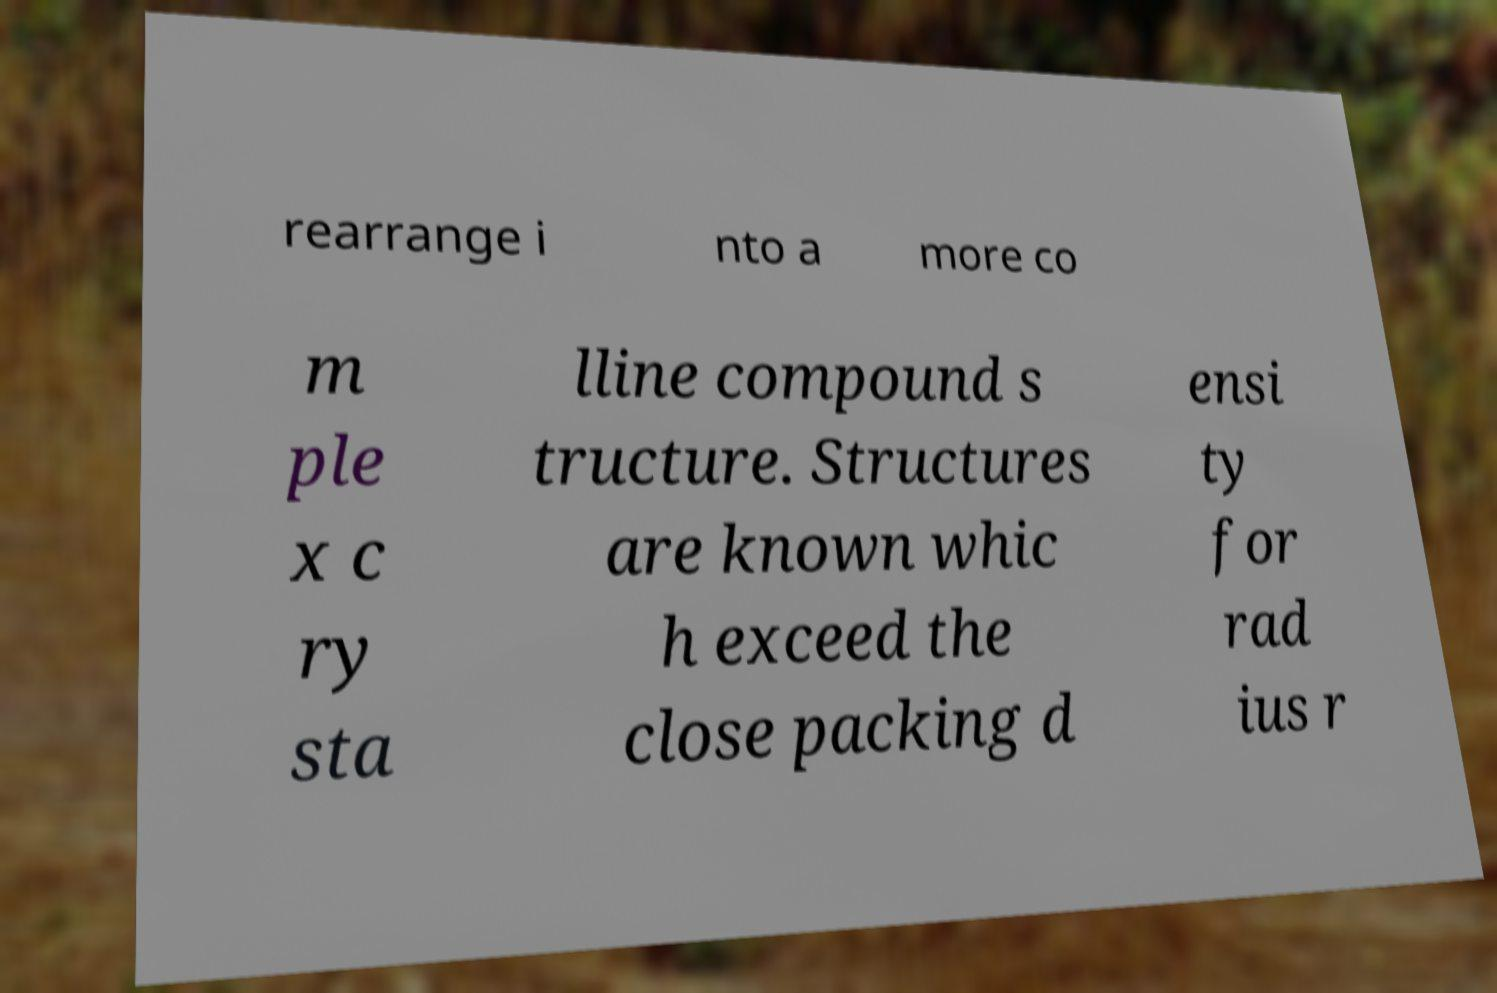There's text embedded in this image that I need extracted. Can you transcribe it verbatim? rearrange i nto a more co m ple x c ry sta lline compound s tructure. Structures are known whic h exceed the close packing d ensi ty for rad ius r 